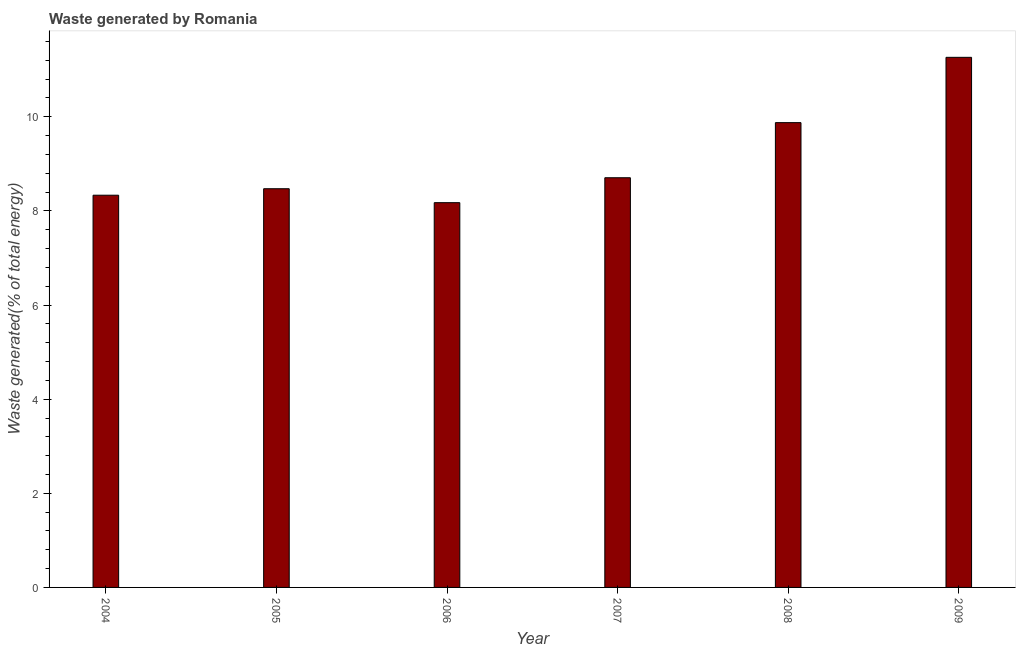Does the graph contain grids?
Keep it short and to the point. No. What is the title of the graph?
Make the answer very short. Waste generated by Romania. What is the label or title of the Y-axis?
Provide a succinct answer. Waste generated(% of total energy). What is the amount of waste generated in 2009?
Your answer should be very brief. 11.26. Across all years, what is the maximum amount of waste generated?
Ensure brevity in your answer.  11.26. Across all years, what is the minimum amount of waste generated?
Your response must be concise. 8.18. What is the sum of the amount of waste generated?
Give a very brief answer. 54.83. What is the difference between the amount of waste generated in 2008 and 2009?
Your answer should be compact. -1.39. What is the average amount of waste generated per year?
Provide a succinct answer. 9.14. What is the median amount of waste generated?
Give a very brief answer. 8.59. Is the amount of waste generated in 2004 less than that in 2007?
Your response must be concise. Yes. Is the difference between the amount of waste generated in 2005 and 2009 greater than the difference between any two years?
Offer a very short reply. No. What is the difference between the highest and the second highest amount of waste generated?
Offer a terse response. 1.39. Is the sum of the amount of waste generated in 2004 and 2006 greater than the maximum amount of waste generated across all years?
Your answer should be compact. Yes. What is the difference between the highest and the lowest amount of waste generated?
Your response must be concise. 3.09. In how many years, is the amount of waste generated greater than the average amount of waste generated taken over all years?
Your answer should be very brief. 2. How many bars are there?
Your answer should be compact. 6. Are all the bars in the graph horizontal?
Your response must be concise. No. What is the difference between two consecutive major ticks on the Y-axis?
Keep it short and to the point. 2. What is the Waste generated(% of total energy) in 2004?
Ensure brevity in your answer.  8.33. What is the Waste generated(% of total energy) in 2005?
Ensure brevity in your answer.  8.47. What is the Waste generated(% of total energy) in 2006?
Your answer should be very brief. 8.18. What is the Waste generated(% of total energy) of 2007?
Your answer should be very brief. 8.71. What is the Waste generated(% of total energy) of 2008?
Your answer should be very brief. 9.88. What is the Waste generated(% of total energy) of 2009?
Your response must be concise. 11.26. What is the difference between the Waste generated(% of total energy) in 2004 and 2005?
Offer a very short reply. -0.14. What is the difference between the Waste generated(% of total energy) in 2004 and 2006?
Offer a very short reply. 0.16. What is the difference between the Waste generated(% of total energy) in 2004 and 2007?
Offer a terse response. -0.37. What is the difference between the Waste generated(% of total energy) in 2004 and 2008?
Your answer should be compact. -1.54. What is the difference between the Waste generated(% of total energy) in 2004 and 2009?
Your answer should be very brief. -2.93. What is the difference between the Waste generated(% of total energy) in 2005 and 2006?
Ensure brevity in your answer.  0.3. What is the difference between the Waste generated(% of total energy) in 2005 and 2007?
Provide a succinct answer. -0.23. What is the difference between the Waste generated(% of total energy) in 2005 and 2008?
Make the answer very short. -1.4. What is the difference between the Waste generated(% of total energy) in 2005 and 2009?
Your answer should be compact. -2.79. What is the difference between the Waste generated(% of total energy) in 2006 and 2007?
Your response must be concise. -0.53. What is the difference between the Waste generated(% of total energy) in 2006 and 2008?
Provide a short and direct response. -1.7. What is the difference between the Waste generated(% of total energy) in 2006 and 2009?
Provide a succinct answer. -3.09. What is the difference between the Waste generated(% of total energy) in 2007 and 2008?
Keep it short and to the point. -1.17. What is the difference between the Waste generated(% of total energy) in 2007 and 2009?
Your response must be concise. -2.56. What is the difference between the Waste generated(% of total energy) in 2008 and 2009?
Keep it short and to the point. -1.39. What is the ratio of the Waste generated(% of total energy) in 2004 to that in 2005?
Your response must be concise. 0.98. What is the ratio of the Waste generated(% of total energy) in 2004 to that in 2007?
Give a very brief answer. 0.96. What is the ratio of the Waste generated(% of total energy) in 2004 to that in 2008?
Your response must be concise. 0.84. What is the ratio of the Waste generated(% of total energy) in 2004 to that in 2009?
Keep it short and to the point. 0.74. What is the ratio of the Waste generated(% of total energy) in 2005 to that in 2006?
Offer a terse response. 1.04. What is the ratio of the Waste generated(% of total energy) in 2005 to that in 2008?
Provide a short and direct response. 0.86. What is the ratio of the Waste generated(% of total energy) in 2005 to that in 2009?
Provide a short and direct response. 0.75. What is the ratio of the Waste generated(% of total energy) in 2006 to that in 2007?
Your answer should be very brief. 0.94. What is the ratio of the Waste generated(% of total energy) in 2006 to that in 2008?
Ensure brevity in your answer.  0.83. What is the ratio of the Waste generated(% of total energy) in 2006 to that in 2009?
Provide a short and direct response. 0.73. What is the ratio of the Waste generated(% of total energy) in 2007 to that in 2008?
Your response must be concise. 0.88. What is the ratio of the Waste generated(% of total energy) in 2007 to that in 2009?
Your answer should be compact. 0.77. What is the ratio of the Waste generated(% of total energy) in 2008 to that in 2009?
Keep it short and to the point. 0.88. 